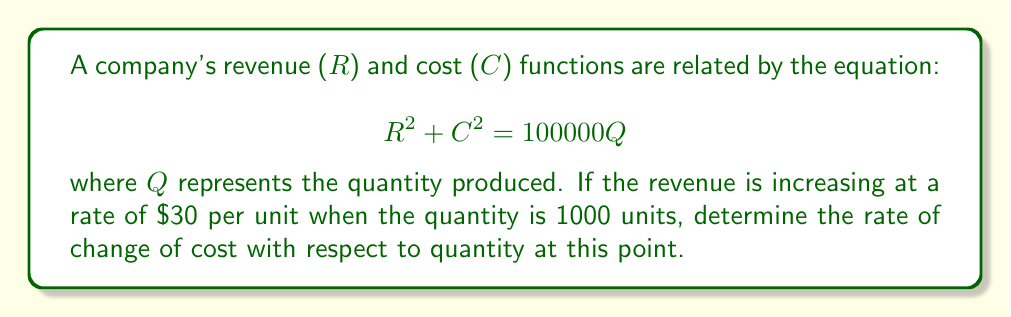Could you help me with this problem? Let's approach this step-by-step using implicit differentiation:

1) First, we differentiate both sides of the equation with respect to Q:

   $$\frac{d}{dQ}(R^2 + C^2) = \frac{d}{dQ}(100000Q)$$

2) Using the chain rule and implicit differentiation:

   $$2R\frac{dR}{dQ} + 2C\frac{dC}{dQ} = 100000$$

3) Divide both sides by 2:

   $$R\frac{dR}{dQ} + C\frac{dC}{dQ} = 50000$$

4) We're given that $\frac{dR}{dQ} = 30$ when $Q = 1000$. Let's substitute this:

   $$30R + C\frac{dC}{dQ} = 50000$$

5) We need to find R and C when Q = 1000. From the original equation:

   $$R^2 + C^2 = 100000(1000) = 100000000$$

6) We're also told that $\frac{dR}{dQ} = 30$, so we can find R:

   $$R = \sqrt{100000000 - C^2}$$

7) Substitute this into the equation from step 4:

   $$30\sqrt{100000000 - C^2} + C\frac{dC}{dQ} = 50000$$

8) Solve for $\frac{dC}{dQ}$:

   $$\frac{dC}{dQ} = \frac{50000 - 30\sqrt{100000000 - C^2}}{C}$$

This is the rate of change of cost with respect to quantity, expressed in terms of C.
Answer: $\frac{dC}{dQ} = \frac{50000 - 30\sqrt{100000000 - C^2}}{C}$ 